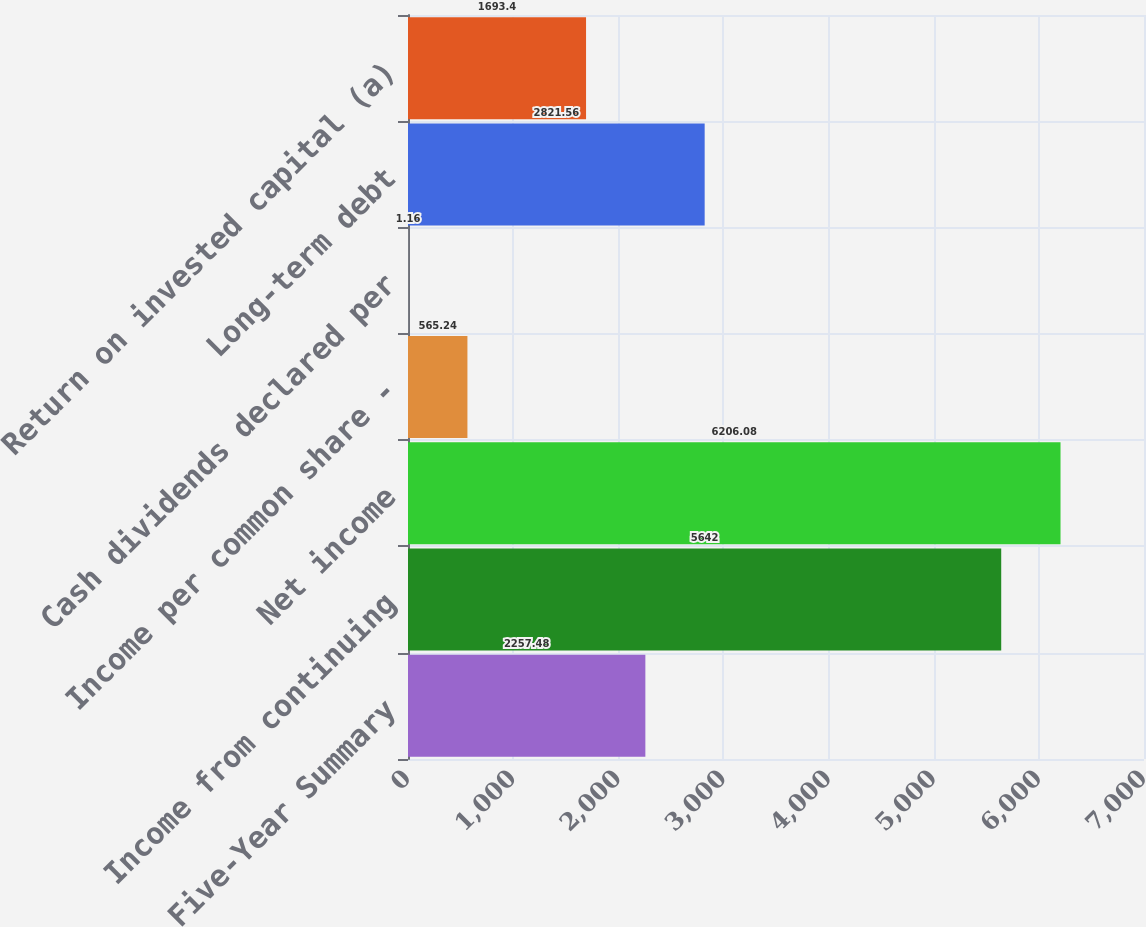Convert chart to OTSL. <chart><loc_0><loc_0><loc_500><loc_500><bar_chart><fcel>Five-Year Summary<fcel>Income from continuing<fcel>Net income<fcel>Income per common share -<fcel>Cash dividends declared per<fcel>Long-term debt<fcel>Return on invested capital (a)<nl><fcel>2257.48<fcel>5642<fcel>6206.08<fcel>565.24<fcel>1.16<fcel>2821.56<fcel>1693.4<nl></chart> 